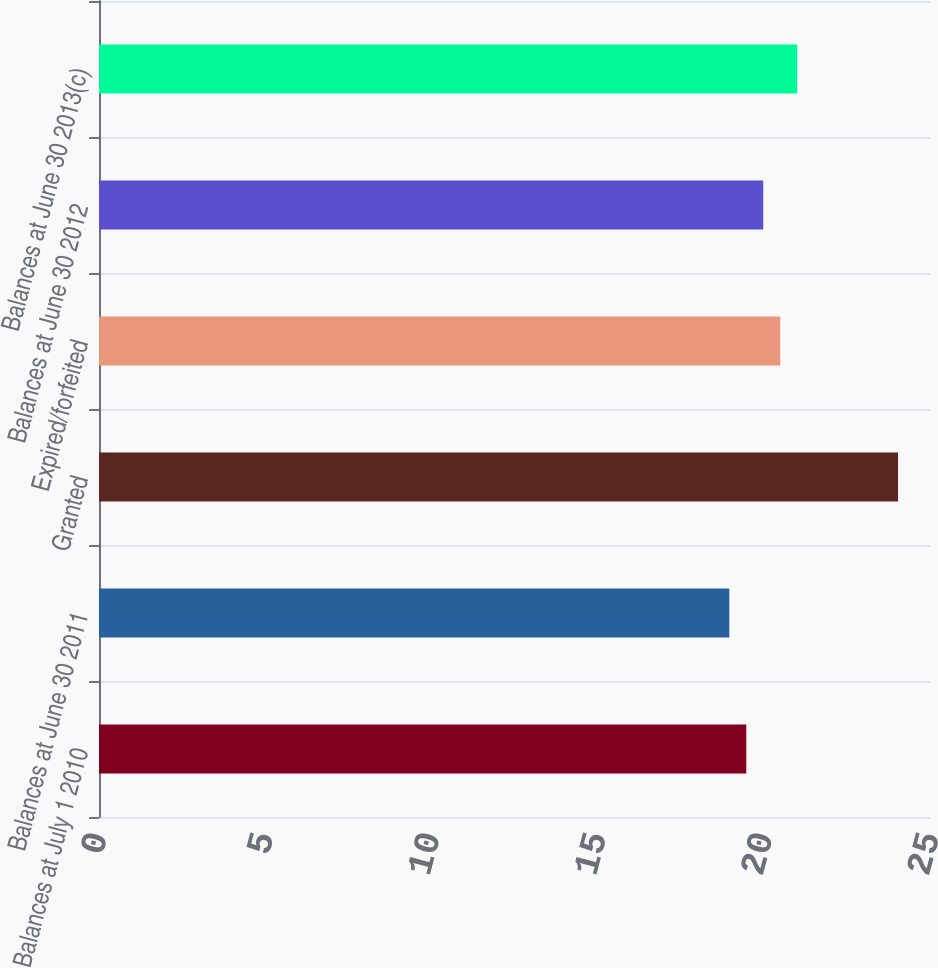Convert chart. <chart><loc_0><loc_0><loc_500><loc_500><bar_chart><fcel>Balances at July 1 2010<fcel>Balances at June 30 2011<fcel>Granted<fcel>Expired/forfeited<fcel>Balances at June 30 2012<fcel>Balances at June 30 2013(c)<nl><fcel>19.45<fcel>18.94<fcel>24.01<fcel>20.47<fcel>19.96<fcel>20.98<nl></chart> 